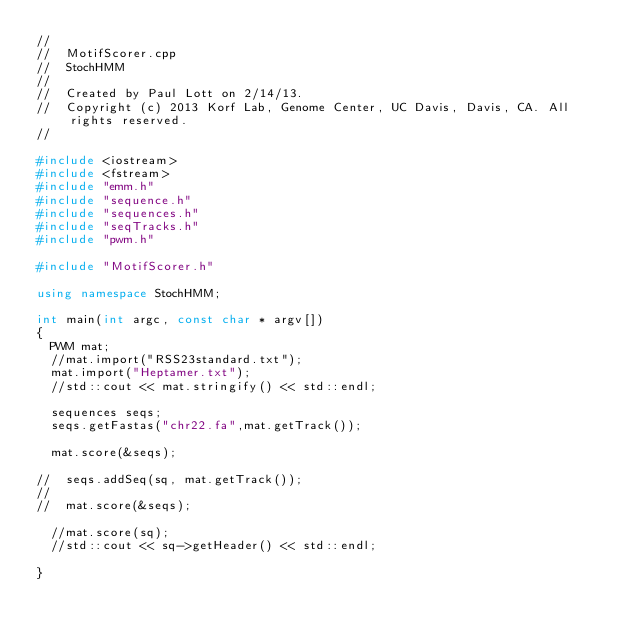Convert code to text. <code><loc_0><loc_0><loc_500><loc_500><_C++_>//
//  MotifScorer.cpp
//  StochHMM
//
//  Created by Paul Lott on 2/14/13.
//  Copyright (c) 2013 Korf Lab, Genome Center, UC Davis, Davis, CA. All rights reserved.
//

#include <iostream>
#include <fstream>
#include "emm.h"
#include "sequence.h"
#include "sequences.h"
#include "seqTracks.h"
#include "pwm.h"

#include "MotifScorer.h"

using namespace StochHMM;

int main(int argc, const char * argv[])
{
	PWM mat;
	//mat.import("RSS23standard.txt");
	mat.import("Heptamer.txt");
	//std::cout << mat.stringify() << std::endl;
	
	sequences seqs;
	seqs.getFastas("chr22.fa",mat.getTrack());
	
	mat.score(&seqs);
	
//	seqs.addSeq(sq, mat.getTrack());
//	
//	mat.score(&seqs);
	
	//mat.score(sq);
	//std::cout << sq->getHeader() << std::endl;
	
}

</code> 